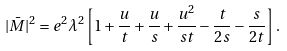<formula> <loc_0><loc_0><loc_500><loc_500>| \bar { M } | ^ { 2 } = e ^ { 2 } \lambda ^ { 2 } \left [ 1 + \frac { u } { t } + \frac { u } { s } + \frac { u ^ { 2 } } { s t } - \frac { t } { 2 s } - \frac { s } { 2 t } \right ] .</formula> 